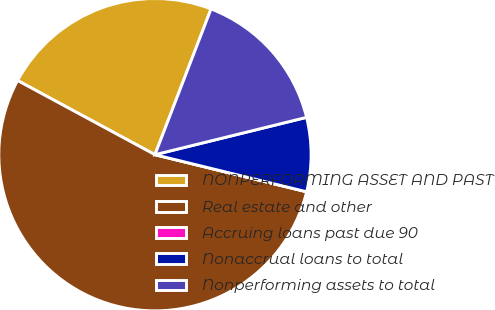Convert chart to OTSL. <chart><loc_0><loc_0><loc_500><loc_500><pie_chart><fcel>NONPERFORMING ASSET AND PAST<fcel>Real estate and other<fcel>Accruing loans past due 90<fcel>Nonaccrual loans to total<fcel>Nonperforming assets to total<nl><fcel>22.97%<fcel>54.06%<fcel>0.0%<fcel>7.66%<fcel>15.31%<nl></chart> 